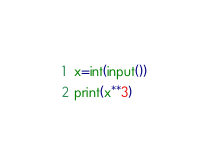Convert code to text. <code><loc_0><loc_0><loc_500><loc_500><_Python_>x=int(input())
print(x**3)
</code> 